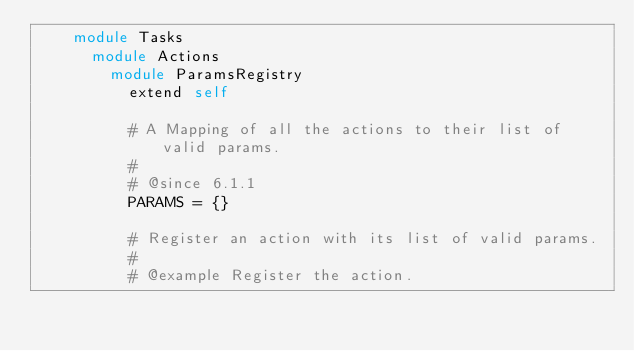<code> <loc_0><loc_0><loc_500><loc_500><_Ruby_>    module Tasks
      module Actions
        module ParamsRegistry
          extend self

          # A Mapping of all the actions to their list of valid params.
          #
          # @since 6.1.1
          PARAMS = {}

          # Register an action with its list of valid params.
          #
          # @example Register the action.</code> 